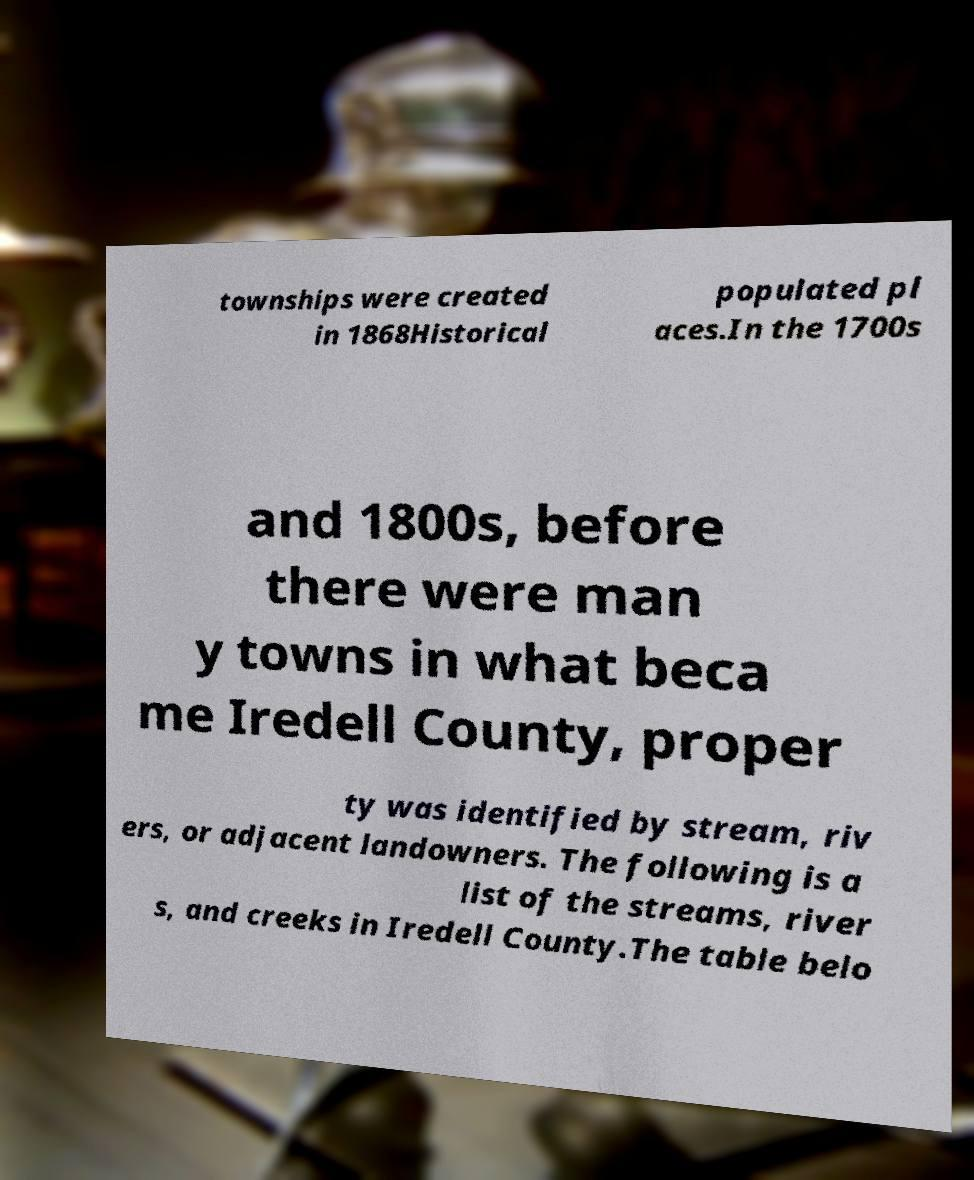Could you assist in decoding the text presented in this image and type it out clearly? townships were created in 1868Historical populated pl aces.In the 1700s and 1800s, before there were man y towns in what beca me Iredell County, proper ty was identified by stream, riv ers, or adjacent landowners. The following is a list of the streams, river s, and creeks in Iredell County.The table belo 